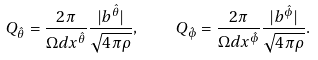Convert formula to latex. <formula><loc_0><loc_0><loc_500><loc_500>Q _ { \hat { \theta } } = \frac { 2 \pi } { \Omega d x ^ { \hat { \theta } } } \frac { | b ^ { \hat { \theta } } | } { \sqrt { 4 \pi \rho } } , \quad Q _ { \hat { \phi } } = \frac { 2 \pi } { \Omega d x ^ { \hat { \phi } } } \frac { | b ^ { \hat { \phi } } | } { \sqrt { 4 \pi \rho } } .</formula> 